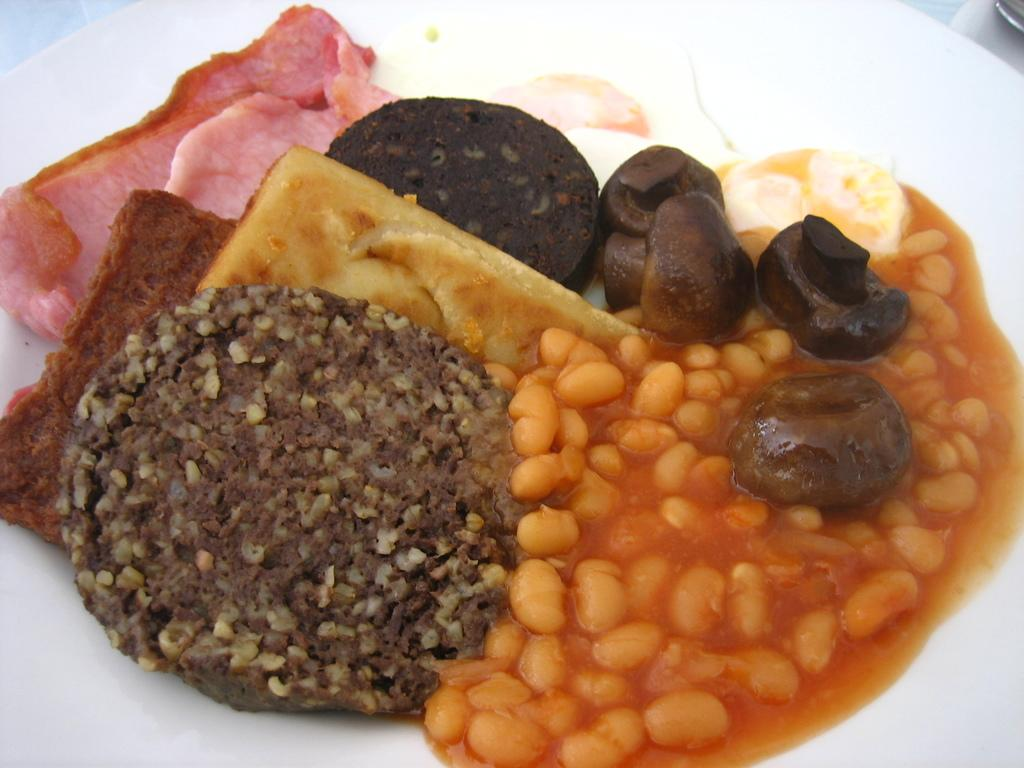What type of food item is made with baked beans in the image? The image contains a food item made with baked beans, but the specific type is not mentioned. What other food item is present in the image? There is bread in the image. What type of cover is used to protect the secretary in the image? There is no secretary or cover present in the image; it only features food items made with baked beans and bread. 